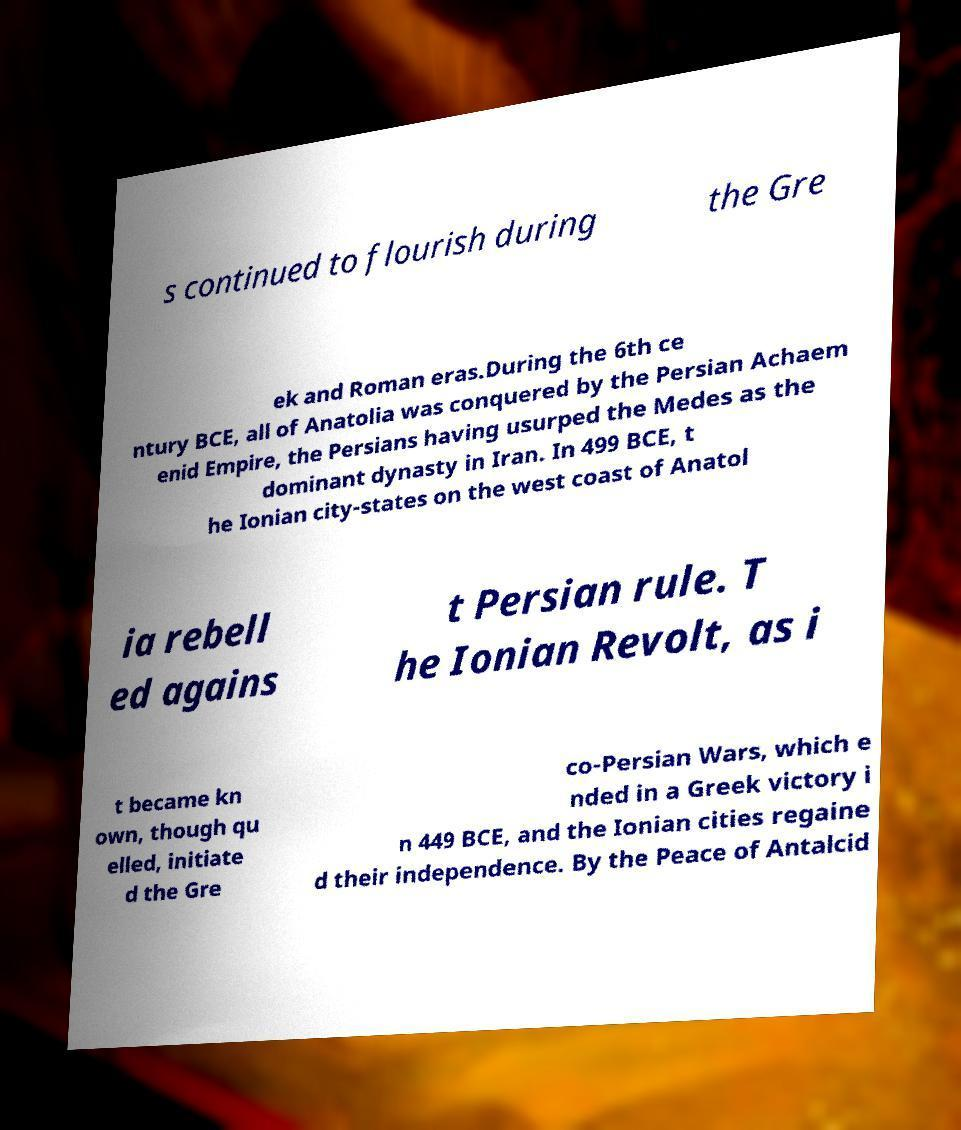There's text embedded in this image that I need extracted. Can you transcribe it verbatim? s continued to flourish during the Gre ek and Roman eras.During the 6th ce ntury BCE, all of Anatolia was conquered by the Persian Achaem enid Empire, the Persians having usurped the Medes as the dominant dynasty in Iran. In 499 BCE, t he Ionian city-states on the west coast of Anatol ia rebell ed agains t Persian rule. T he Ionian Revolt, as i t became kn own, though qu elled, initiate d the Gre co-Persian Wars, which e nded in a Greek victory i n 449 BCE, and the Ionian cities regaine d their independence. By the Peace of Antalcid 